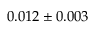Convert formula to latex. <formula><loc_0><loc_0><loc_500><loc_500>0 . 0 1 2 \pm 0 . 0 0 3</formula> 